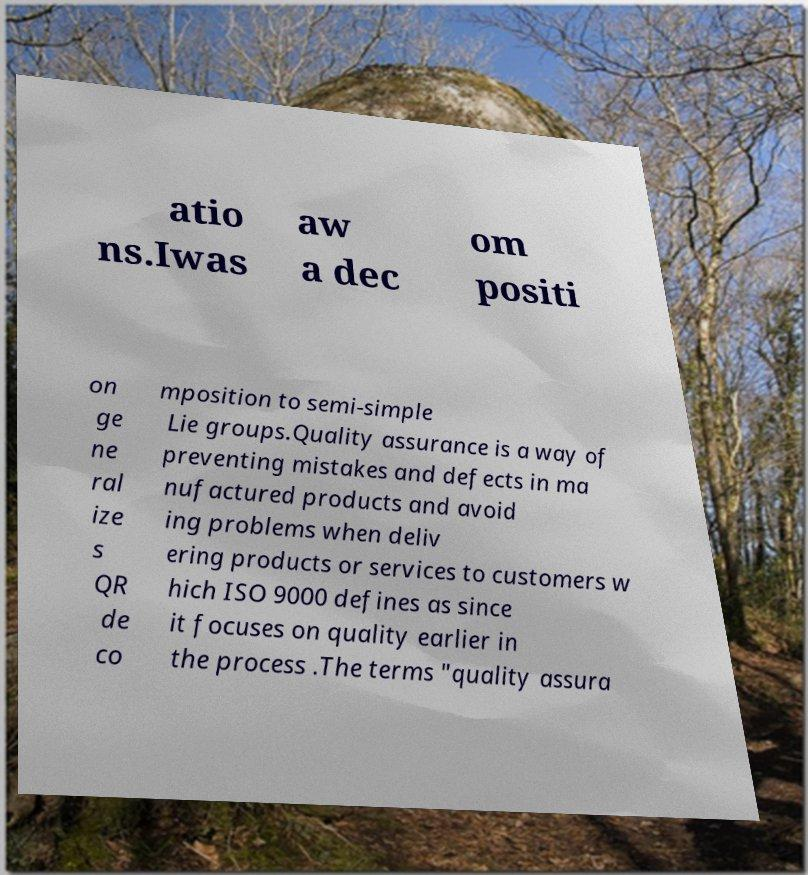Could you assist in decoding the text presented in this image and type it out clearly? atio ns.Iwas aw a dec om positi on ge ne ral ize s QR de co mposition to semi-simple Lie groups.Quality assurance is a way of preventing mistakes and defects in ma nufactured products and avoid ing problems when deliv ering products or services to customers w hich ISO 9000 defines as since it focuses on quality earlier in the process .The terms "quality assura 